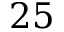<formula> <loc_0><loc_0><loc_500><loc_500>2 5</formula> 